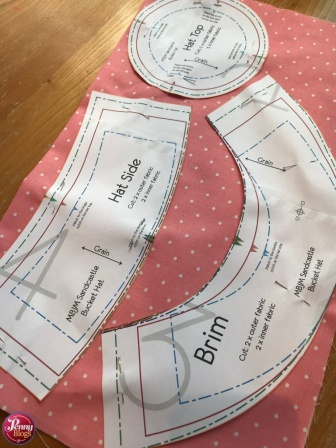What inspirations can one draw from this image for other creative projects? This image is brimming with inspiration for various creative projects. The polka-dotted fabric could inspire designs for cheerful and playful home decor items, like cushions or curtains. The concept of using patterns can motivate one to experiment with crafting clothing or accessories, encouraging the exploration of different fabrics and designs.

The detailed and organized layout of the patterns offers a lesson in the importance of planning and precision in any craft. It can also inspire artists to create patterns for paper art, such as scrapbooking or journaling. The blend of colors and shapes in this image might even prompt a painter to create a whimsical artwork that combines elements of fabric and fashion design. Overall, the image serves as a testament to the beauty of meticulous craftsmanship and the endless possibilities that arise from a single piece of fabric and some creative patterns. How can one repurpose the remaining fabric after making the hat? The remaining fabric after making the hat offers numerous opportunities for creative reuse. Smaller pieces can be used to make matching accessories, such as a fabric belt, bow tie, or hair scrunchies. Leftover fabric can also be crafted into decorative elements like fabric flowers or appliqués that can adorn clothing, bags, or even home decor items.

If the fabric pieces are large enough, they could be stitched together to create a patchwork cushion cover or a small tote bag. For those who enjoy quilting, the fabric can become part of a charming quilt, blending with other patterns and textures to create a unique piece. Alternatively, the leftover fabric could be used in scrapbooking or card making, adding a tactile and personal touch to paper crafts. The key is to see the potential in every fabric scrap and let creativity guide the way to new, imaginative uses. 